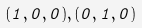<formula> <loc_0><loc_0><loc_500><loc_500>( 1 , 0 , 0 ) , ( 0 , 1 , 0 )</formula> 